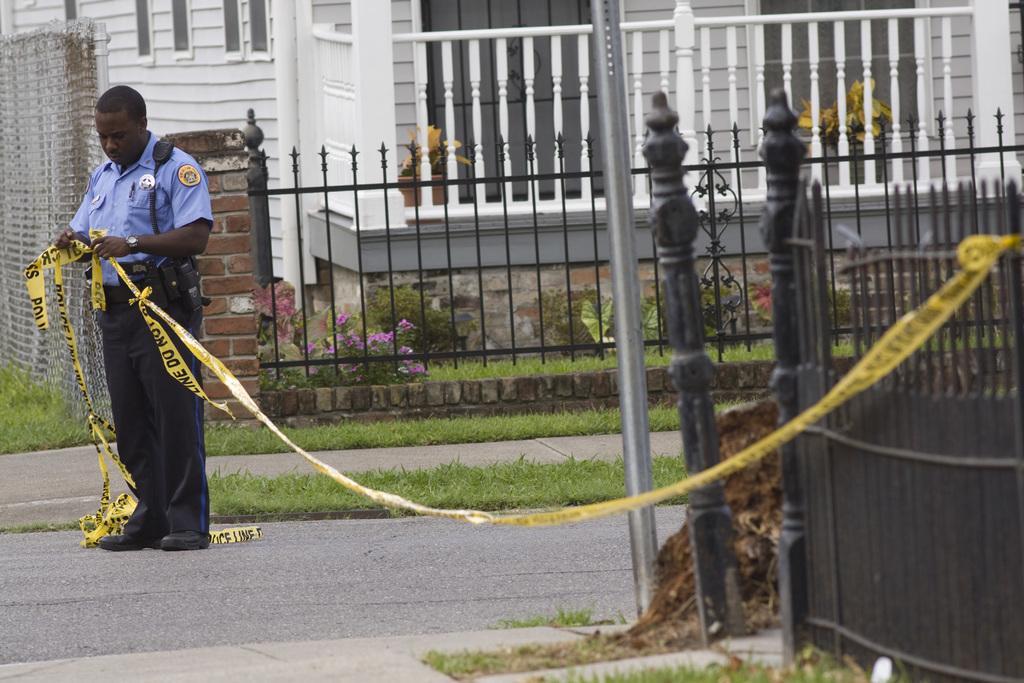How would you summarize this image in a sentence or two? In the picture I can see a police man standing and holding an object which is tightened to a fence in the right corner and there is a fence,few plants and a building in the background. 